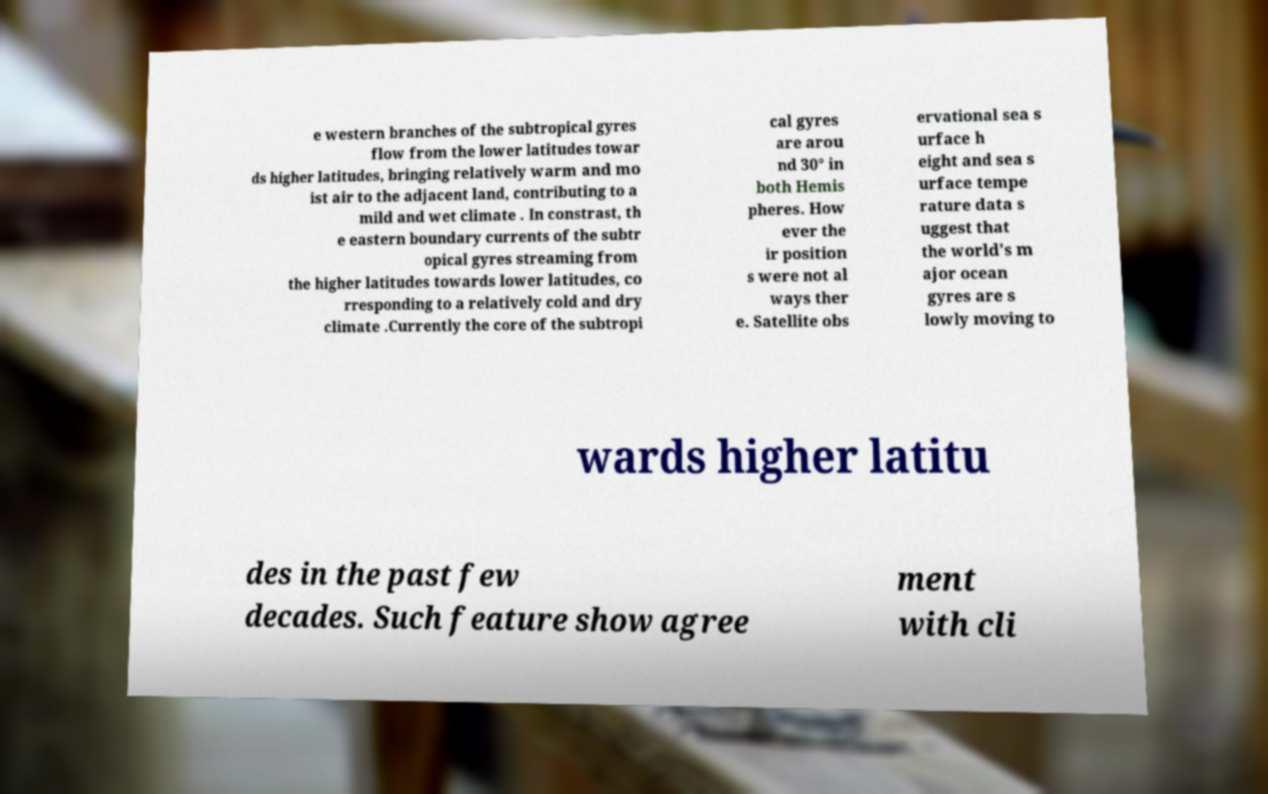Please read and relay the text visible in this image. What does it say? e western branches of the subtropical gyres flow from the lower latitudes towar ds higher latitudes, bringing relatively warm and mo ist air to the adjacent land, contributing to a mild and wet climate . In constrast, th e eastern boundary currents of the subtr opical gyres streaming from the higher latitudes towards lower latitudes, co rresponding to a relatively cold and dry climate .Currently the core of the subtropi cal gyres are arou nd 30° in both Hemis pheres. How ever the ir position s were not al ways ther e. Satellite obs ervational sea s urface h eight and sea s urface tempe rature data s uggest that the world's m ajor ocean gyres are s lowly moving to wards higher latitu des in the past few decades. Such feature show agree ment with cli 